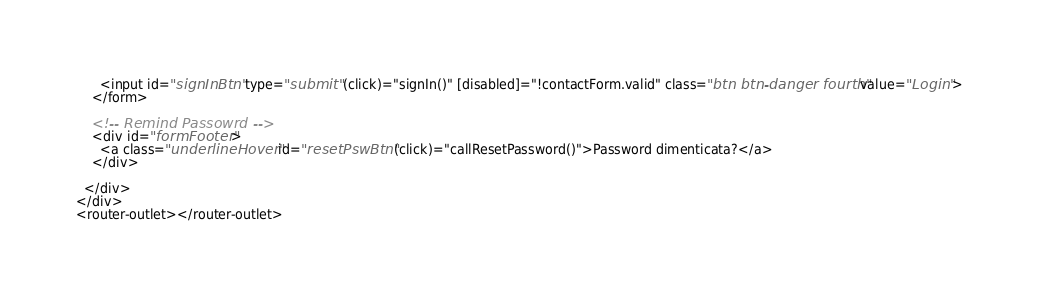<code> <loc_0><loc_0><loc_500><loc_500><_HTML_>      <input id="signInBtn" type="submit" (click)="signIn()" [disabled]="!contactForm.valid" class="btn btn-danger fourth" value="Login">
    </form>

    <!-- Remind Passowrd -->
    <div id="formFooter">
      <a class="underlineHover" id="resetPswBtn" (click)="callResetPassword()">Password dimenticata?</a>
    </div>

  </div>
</div>
<router-outlet></router-outlet>
</code> 